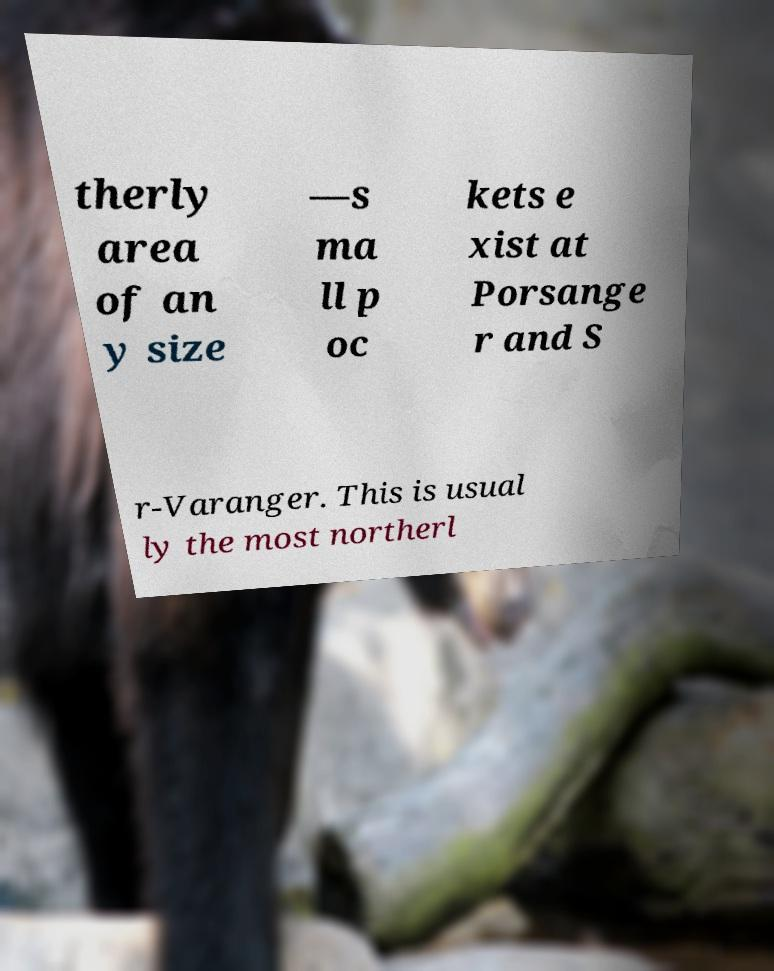Please read and relay the text visible in this image. What does it say? therly area of an y size —s ma ll p oc kets e xist at Porsange r and S r-Varanger. This is usual ly the most northerl 